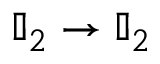Convert formula to latex. <formula><loc_0><loc_0><loc_500><loc_500>\mathbb { I } _ { 2 } \rightarrow \mathbb { I } _ { 2 }</formula> 